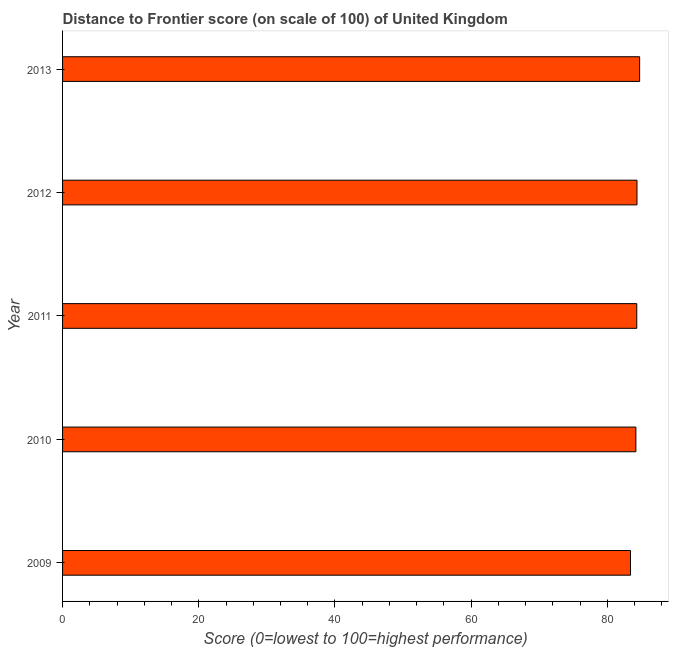Does the graph contain grids?
Offer a terse response. No. What is the title of the graph?
Make the answer very short. Distance to Frontier score (on scale of 100) of United Kingdom. What is the label or title of the X-axis?
Provide a succinct answer. Score (0=lowest to 100=highest performance). What is the label or title of the Y-axis?
Provide a succinct answer. Year. What is the distance to frontier score in 2011?
Provide a short and direct response. 84.32. Across all years, what is the maximum distance to frontier score?
Keep it short and to the point. 84.74. Across all years, what is the minimum distance to frontier score?
Your answer should be very brief. 83.4. In which year was the distance to frontier score maximum?
Offer a very short reply. 2013. In which year was the distance to frontier score minimum?
Provide a short and direct response. 2009. What is the sum of the distance to frontier score?
Give a very brief answer. 421. What is the difference between the distance to frontier score in 2011 and 2012?
Offer a very short reply. -0.03. What is the average distance to frontier score per year?
Give a very brief answer. 84.2. What is the median distance to frontier score?
Provide a succinct answer. 84.32. What is the ratio of the distance to frontier score in 2011 to that in 2012?
Give a very brief answer. 1. Is the distance to frontier score in 2009 less than that in 2010?
Ensure brevity in your answer.  Yes. What is the difference between the highest and the second highest distance to frontier score?
Your response must be concise. 0.39. Is the sum of the distance to frontier score in 2009 and 2012 greater than the maximum distance to frontier score across all years?
Provide a succinct answer. Yes. What is the difference between the highest and the lowest distance to frontier score?
Offer a terse response. 1.34. In how many years, is the distance to frontier score greater than the average distance to frontier score taken over all years?
Your response must be concise. 3. How many bars are there?
Keep it short and to the point. 5. Are all the bars in the graph horizontal?
Ensure brevity in your answer.  Yes. What is the Score (0=lowest to 100=highest performance) in 2009?
Make the answer very short. 83.4. What is the Score (0=lowest to 100=highest performance) of 2010?
Offer a very short reply. 84.19. What is the Score (0=lowest to 100=highest performance) of 2011?
Ensure brevity in your answer.  84.32. What is the Score (0=lowest to 100=highest performance) of 2012?
Offer a terse response. 84.35. What is the Score (0=lowest to 100=highest performance) of 2013?
Ensure brevity in your answer.  84.74. What is the difference between the Score (0=lowest to 100=highest performance) in 2009 and 2010?
Give a very brief answer. -0.79. What is the difference between the Score (0=lowest to 100=highest performance) in 2009 and 2011?
Give a very brief answer. -0.92. What is the difference between the Score (0=lowest to 100=highest performance) in 2009 and 2012?
Your answer should be compact. -0.95. What is the difference between the Score (0=lowest to 100=highest performance) in 2009 and 2013?
Ensure brevity in your answer.  -1.34. What is the difference between the Score (0=lowest to 100=highest performance) in 2010 and 2011?
Provide a short and direct response. -0.13. What is the difference between the Score (0=lowest to 100=highest performance) in 2010 and 2012?
Your response must be concise. -0.16. What is the difference between the Score (0=lowest to 100=highest performance) in 2010 and 2013?
Offer a terse response. -0.55. What is the difference between the Score (0=lowest to 100=highest performance) in 2011 and 2012?
Your answer should be compact. -0.03. What is the difference between the Score (0=lowest to 100=highest performance) in 2011 and 2013?
Give a very brief answer. -0.42. What is the difference between the Score (0=lowest to 100=highest performance) in 2012 and 2013?
Provide a succinct answer. -0.39. What is the ratio of the Score (0=lowest to 100=highest performance) in 2009 to that in 2011?
Offer a very short reply. 0.99. What is the ratio of the Score (0=lowest to 100=highest performance) in 2009 to that in 2013?
Make the answer very short. 0.98. What is the ratio of the Score (0=lowest to 100=highest performance) in 2010 to that in 2012?
Your answer should be very brief. 1. What is the ratio of the Score (0=lowest to 100=highest performance) in 2010 to that in 2013?
Your response must be concise. 0.99. What is the ratio of the Score (0=lowest to 100=highest performance) in 2012 to that in 2013?
Your response must be concise. 0.99. 